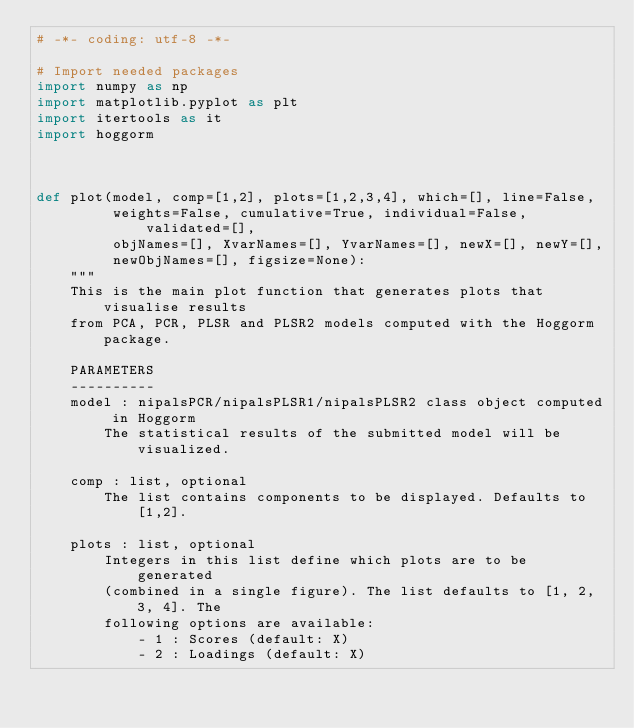Convert code to text. <code><loc_0><loc_0><loc_500><loc_500><_Python_># -*- coding: utf-8 -*-

# Import needed packages
import numpy as np
import matplotlib.pyplot as plt
import itertools as it
import hoggorm



def plot(model, comp=[1,2], plots=[1,2,3,4], which=[], line=False, 
         weights=False, cumulative=True, individual=False, validated=[],
         objNames=[], XvarNames=[], YvarNames=[], newX=[], newY=[], 
         newObjNames=[], figsize=None):
    """
    This is the main plot function that generates plots that visualise results 
    from PCA, PCR, PLSR and PLSR2 models computed with the Hoggorm package.
    
    PARAMETERS
    ----------
    model : nipalsPCR/nipalsPLSR1/nipalsPLSR2 class object computed in Hoggorm 
        The statistical results of the submitted model will be visualized.
    
    comp : list, optional
        The list contains components to be displayed. Defaults to [1,2].
    
    plots : list, optional
        Integers in this list define which plots are to be generated 
        (combined in a single figure). The list defaults to [1, 2, 3, 4]. The 
        following options are available:
            - 1 : Scores (default: X)
            - 2 : Loadings (default: X)</code> 